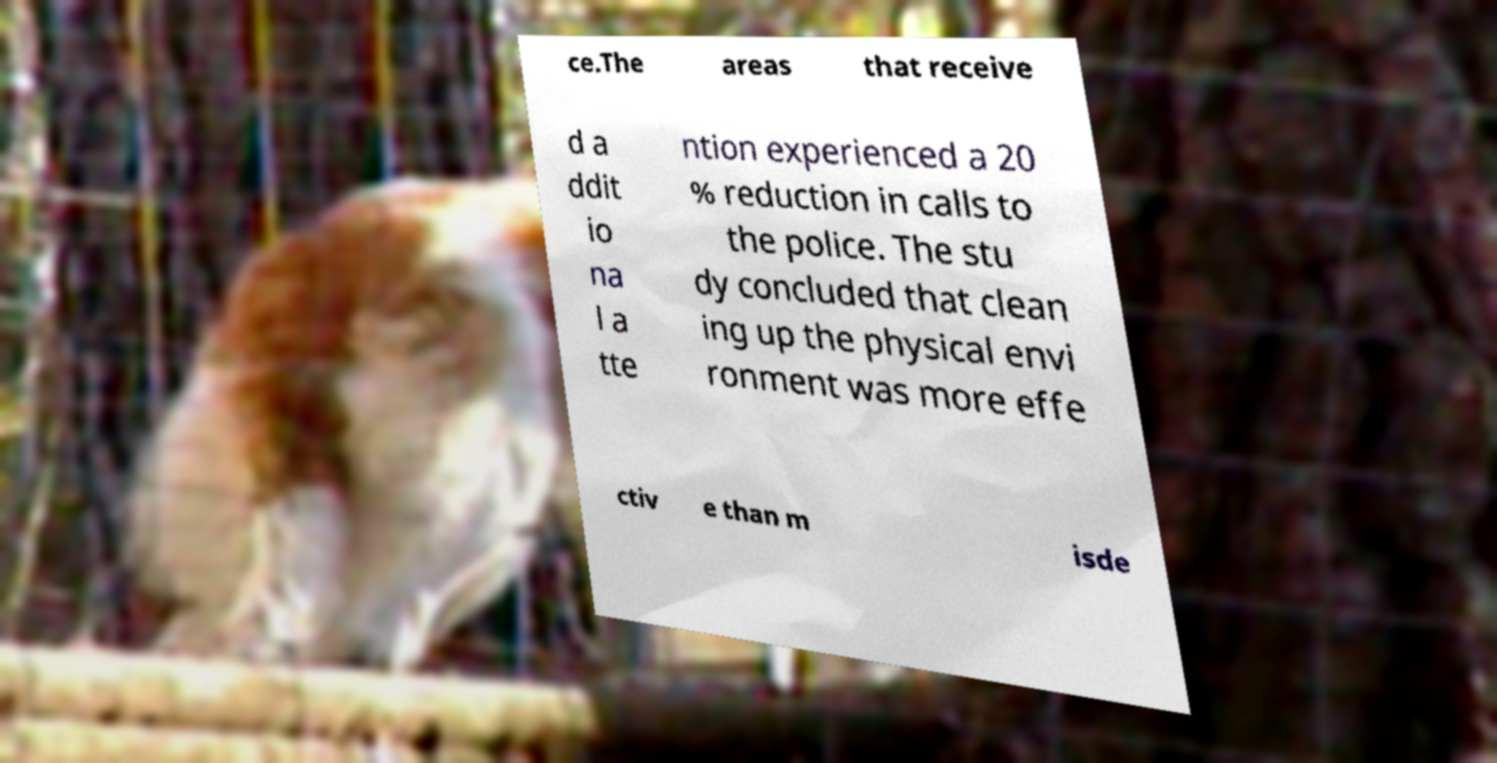There's text embedded in this image that I need extracted. Can you transcribe it verbatim? ce.The areas that receive d a ddit io na l a tte ntion experienced a 20 % reduction in calls to the police. The stu dy concluded that clean ing up the physical envi ronment was more effe ctiv e than m isde 